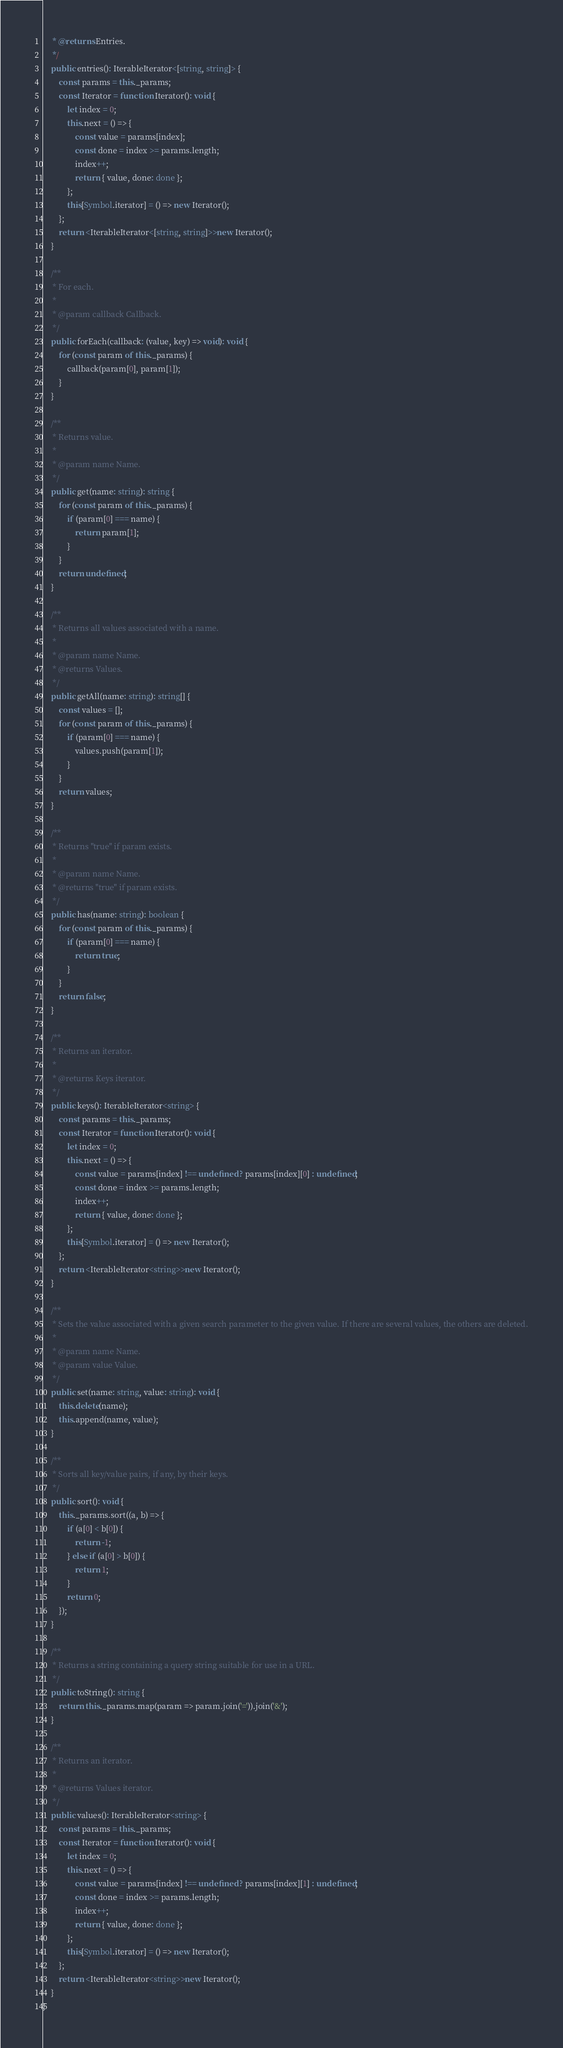Convert code to text. <code><loc_0><loc_0><loc_500><loc_500><_TypeScript_>	 * @returns Entries.
	 */
	public entries(): IterableIterator<[string, string]> {
		const params = this._params;
		const Iterator = function Iterator(): void {
			let index = 0;
			this.next = () => {
				const value = params[index];
				const done = index >= params.length;
				index++;
				return { value, done: done };
			};
			this[Symbol.iterator] = () => new Iterator();
		};
		return <IterableIterator<[string, string]>>new Iterator();
	}

	/**
	 * For each.
	 *
	 * @param callback Callback.
	 */
	public forEach(callback: (value, key) => void): void {
		for (const param of this._params) {
			callback(param[0], param[1]);
		}
	}

	/**
	 * Returns value.
	 *
	 * @param name Name.
	 */
	public get(name: string): string {
		for (const param of this._params) {
			if (param[0] === name) {
				return param[1];
			}
		}
		return undefined;
	}

	/**
	 * Returns all values associated with a name.
	 *
	 * @param name Name.
	 * @returns Values.
	 */
	public getAll(name: string): string[] {
		const values = [];
		for (const param of this._params) {
			if (param[0] === name) {
				values.push(param[1]);
			}
		}
		return values;
	}

	/**
	 * Returns "true" if param exists.
	 *
	 * @param name Name.
	 * @returns "true" if param exists.
	 */
	public has(name: string): boolean {
		for (const param of this._params) {
			if (param[0] === name) {
				return true;
			}
		}
		return false;
	}

	/**
	 * Returns an iterator.
	 *
	 * @returns Keys iterator.
	 */
	public keys(): IterableIterator<string> {
		const params = this._params;
		const Iterator = function Iterator(): void {
			let index = 0;
			this.next = () => {
				const value = params[index] !== undefined ? params[index][0] : undefined;
				const done = index >= params.length;
				index++;
				return { value, done: done };
			};
			this[Symbol.iterator] = () => new Iterator();
		};
		return <IterableIterator<string>>new Iterator();
	}

	/**
	 * Sets the value associated with a given search parameter to the given value. If there are several values, the others are deleted.
	 *
	 * @param name Name.
	 * @param value Value.
	 */
	public set(name: string, value: string): void {
		this.delete(name);
		this.append(name, value);
	}

	/**
	 * Sorts all key/value pairs, if any, by their keys.
	 */
	public sort(): void {
		this._params.sort((a, b) => {
			if (a[0] < b[0]) {
				return -1;
			} else if (a[0] > b[0]) {
				return 1;
			}
			return 0;
		});
	}

	/**
	 * Returns a string containing a query string suitable for use in a URL.
	 */
	public toString(): string {
		return this._params.map(param => param.join('=')).join('&');
	}

	/**
	 * Returns an iterator.
	 *
	 * @returns Values iterator.
	 */
	public values(): IterableIterator<string> {
		const params = this._params;
		const Iterator = function Iterator(): void {
			let index = 0;
			this.next = () => {
				const value = params[index] !== undefined ? params[index][1] : undefined;
				const done = index >= params.length;
				index++;
				return { value, done: done };
			};
			this[Symbol.iterator] = () => new Iterator();
		};
		return <IterableIterator<string>>new Iterator();
	}
}
</code> 